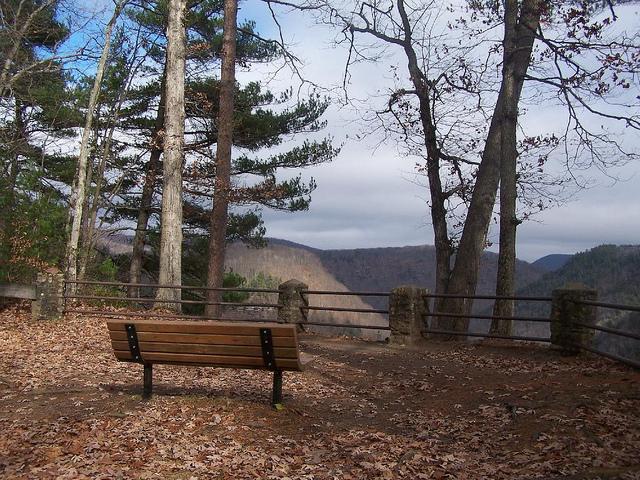Is the bench sitting in the middle of leaves?
Write a very short answer. Yes. Is the bench in the woods?
Short answer required. Yes. What kind of ground is the bench on?
Keep it brief. Dirt. Is the bench for looking at a building?
Be succinct. No. What color is the bench?
Quick response, please. Brown. Is there a house design in this picture?
Be succinct. No. Why is the railing there?
Concise answer only. Safety. 